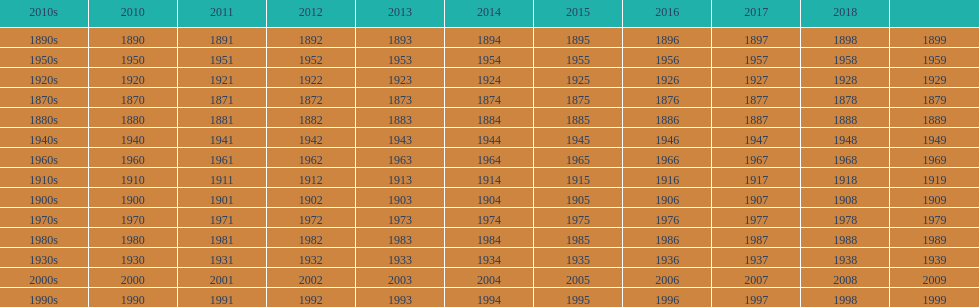What is the earliest year that a film was released? 1870. 